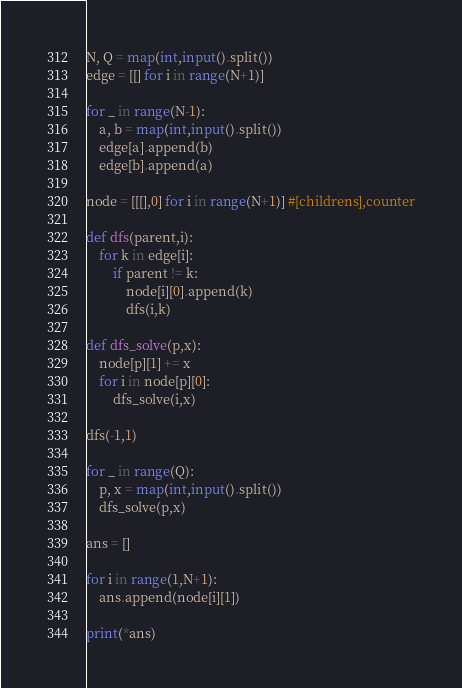<code> <loc_0><loc_0><loc_500><loc_500><_Python_>N, Q = map(int,input().split())
edge = [[] for i in range(N+1)]

for _ in range(N-1):
    a, b = map(int,input().split())
    edge[a].append(b)
    edge[b].append(a)

node = [[[],0] for i in range(N+1)] #[childrens],counter
    
def dfs(parent,i):
    for k in edge[i]:
        if parent != k:
            node[i][0].append(k)
            dfs(i,k)

def dfs_solve(p,x):
    node[p][1] += x
    for i in node[p][0]:
        dfs_solve(i,x)
        
dfs(-1,1)

for _ in range(Q):
    p, x = map(int,input().split())
    dfs_solve(p,x)

ans = []

for i in range(1,N+1):
    ans.append(node[i][1])

print(*ans)</code> 